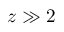<formula> <loc_0><loc_0><loc_500><loc_500>z \gg 2</formula> 